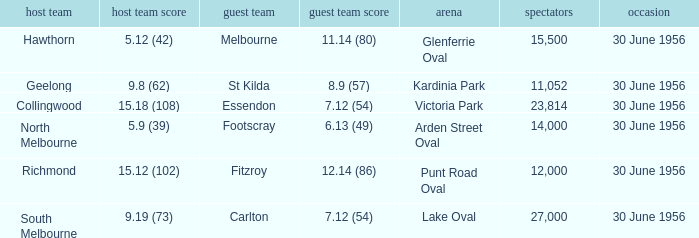What is the home team score when the away team is Melbourne? 5.12 (42). Parse the full table. {'header': ['host team', 'host team score', 'guest team', 'guest team score', 'arena', 'spectators', 'occasion'], 'rows': [['Hawthorn', '5.12 (42)', 'Melbourne', '11.14 (80)', 'Glenferrie Oval', '15,500', '30 June 1956'], ['Geelong', '9.8 (62)', 'St Kilda', '8.9 (57)', 'Kardinia Park', '11,052', '30 June 1956'], ['Collingwood', '15.18 (108)', 'Essendon', '7.12 (54)', 'Victoria Park', '23,814', '30 June 1956'], ['North Melbourne', '5.9 (39)', 'Footscray', '6.13 (49)', 'Arden Street Oval', '14,000', '30 June 1956'], ['Richmond', '15.12 (102)', 'Fitzroy', '12.14 (86)', 'Punt Road Oval', '12,000', '30 June 1956'], ['South Melbourne', '9.19 (73)', 'Carlton', '7.12 (54)', 'Lake Oval', '27,000', '30 June 1956']]} 